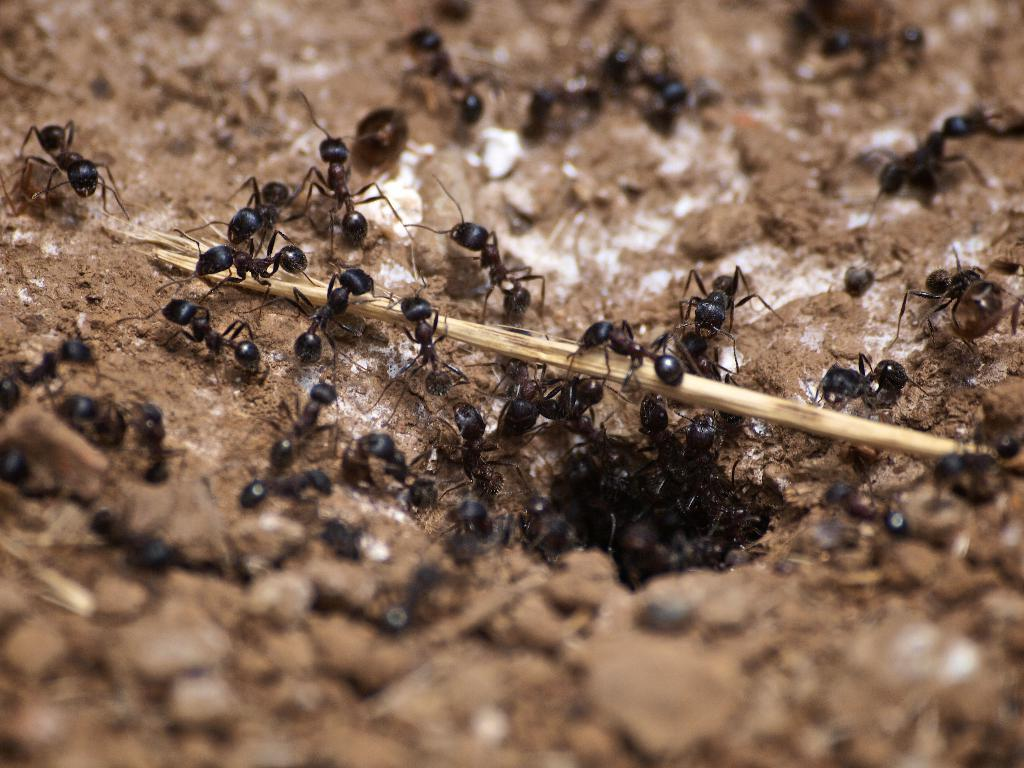What type of insects are present in the image? There are many black ants in the image. What is the surface on which the ants are located? The ants are on a sand surface. What is the reason behind the ants' development in the image? The image does not provide information about the ants' development or any reasons behind it. 